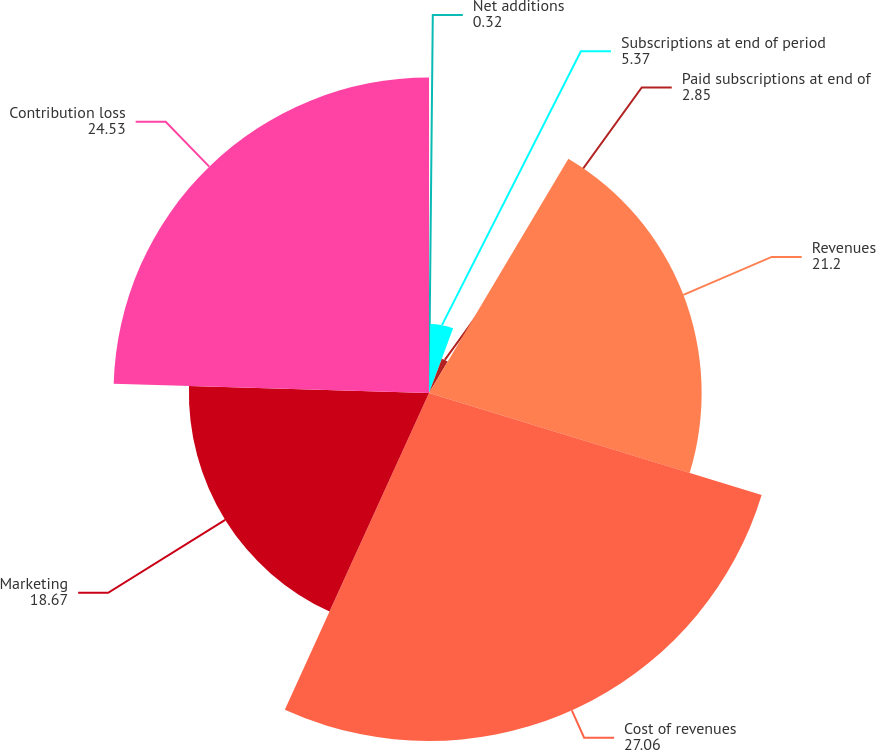Convert chart to OTSL. <chart><loc_0><loc_0><loc_500><loc_500><pie_chart><fcel>Net additions<fcel>Subscriptions at end of period<fcel>Paid subscriptions at end of<fcel>Revenues<fcel>Cost of revenues<fcel>Marketing<fcel>Contribution loss<nl><fcel>0.32%<fcel>5.37%<fcel>2.85%<fcel>21.2%<fcel>27.06%<fcel>18.67%<fcel>24.53%<nl></chart> 